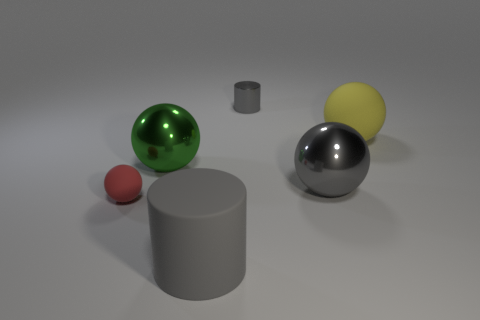Add 2 big balls. How many objects exist? 8 Subtract all balls. How many objects are left? 2 Subtract all large gray spheres. Subtract all metal spheres. How many objects are left? 3 Add 1 gray cylinders. How many gray cylinders are left? 3 Add 2 large yellow spheres. How many large yellow spheres exist? 3 Subtract 0 red blocks. How many objects are left? 6 